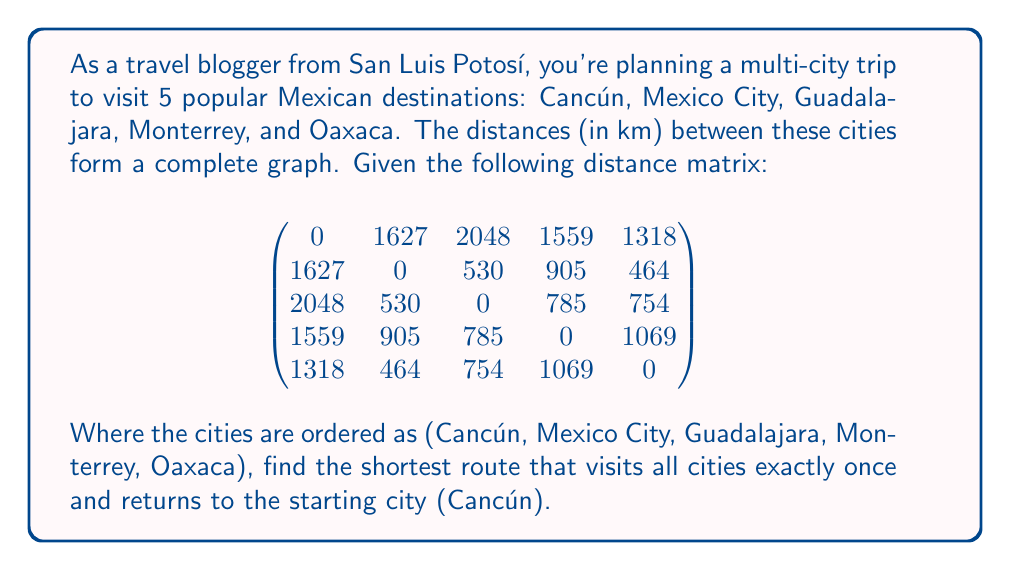Teach me how to tackle this problem. To solve this problem, we'll use the concept of the Traveling Salesman Problem (TSP) from graph theory. Since we have a small number of cities, we can use a brute-force approach to find the optimal solution.

Step 1: List all possible permutations of the cities (excluding Cancún, as it's the fixed start and end point).
There are 4! = 24 possible permutations.

Step 2: For each permutation, calculate the total distance of the route.
For example, let's calculate the distance for the route Cancún -> Mexico City -> Guadalajara -> Monterrey -> Oaxaca -> Cancún:

Distance = 1627 + 530 + 785 + 1069 + 1318 = 5329 km

Step 3: Compare all permutations and find the one with the shortest total distance.

After calculating all permutations, we find that the shortest route is:
Cancún -> Mexico City -> Oaxaca -> Guadalajara -> Monterrey -> Cancún

Step 4: Calculate the total distance of the optimal route:
Distance = 1627 + 464 + 754 + 785 + 1559 = 5189 km

Therefore, the shortest route that visits all cities exactly once and returns to Cancún is 5189 km long.
Answer: Cancún -> Mexico City -> Oaxaca -> Guadalajara -> Monterrey -> Cancún, 5189 km 